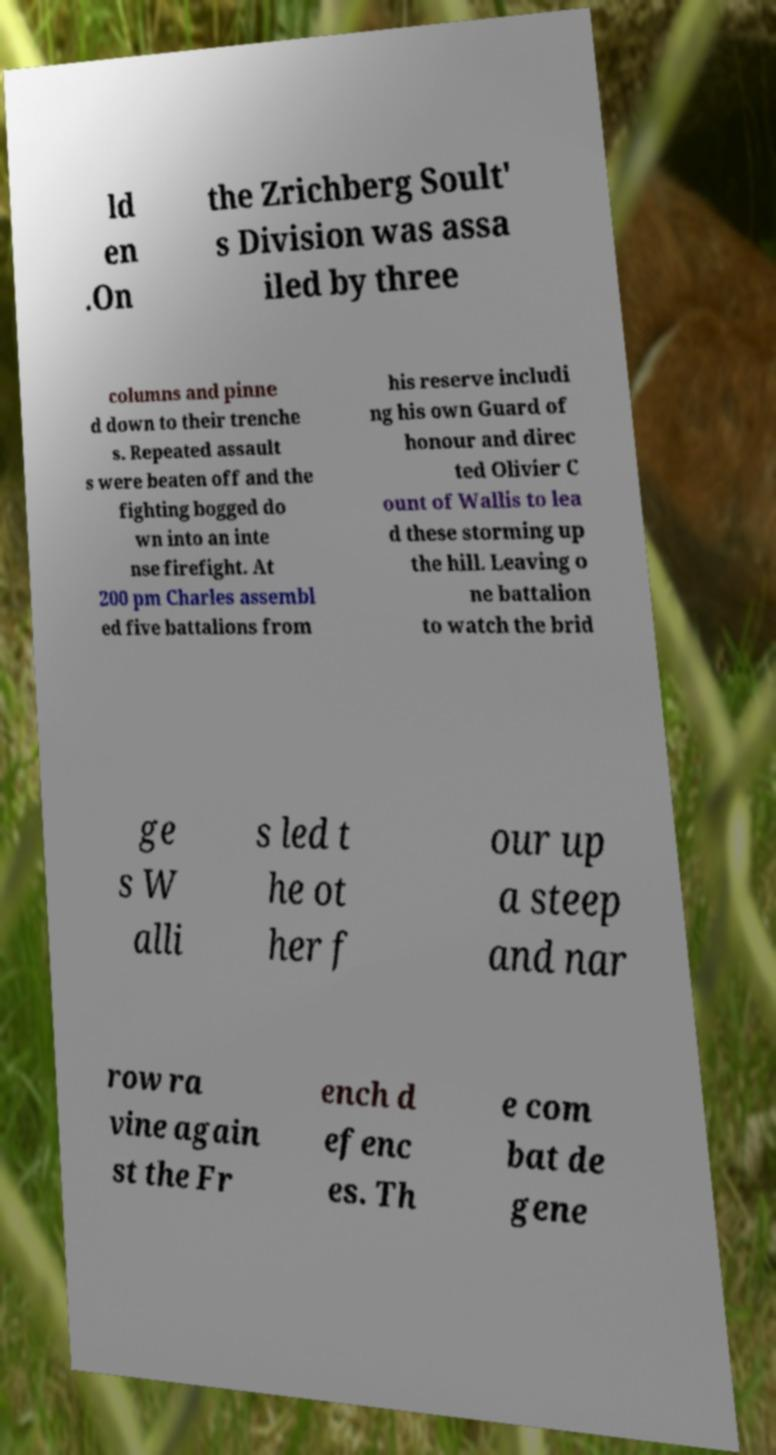There's text embedded in this image that I need extracted. Can you transcribe it verbatim? ld en .On the Zrichberg Soult' s Division was assa iled by three columns and pinne d down to their trenche s. Repeated assault s were beaten off and the fighting bogged do wn into an inte nse firefight. At 200 pm Charles assembl ed five battalions from his reserve includi ng his own Guard of honour and direc ted Olivier C ount of Wallis to lea d these storming up the hill. Leaving o ne battalion to watch the brid ge s W alli s led t he ot her f our up a steep and nar row ra vine again st the Fr ench d efenc es. Th e com bat de gene 